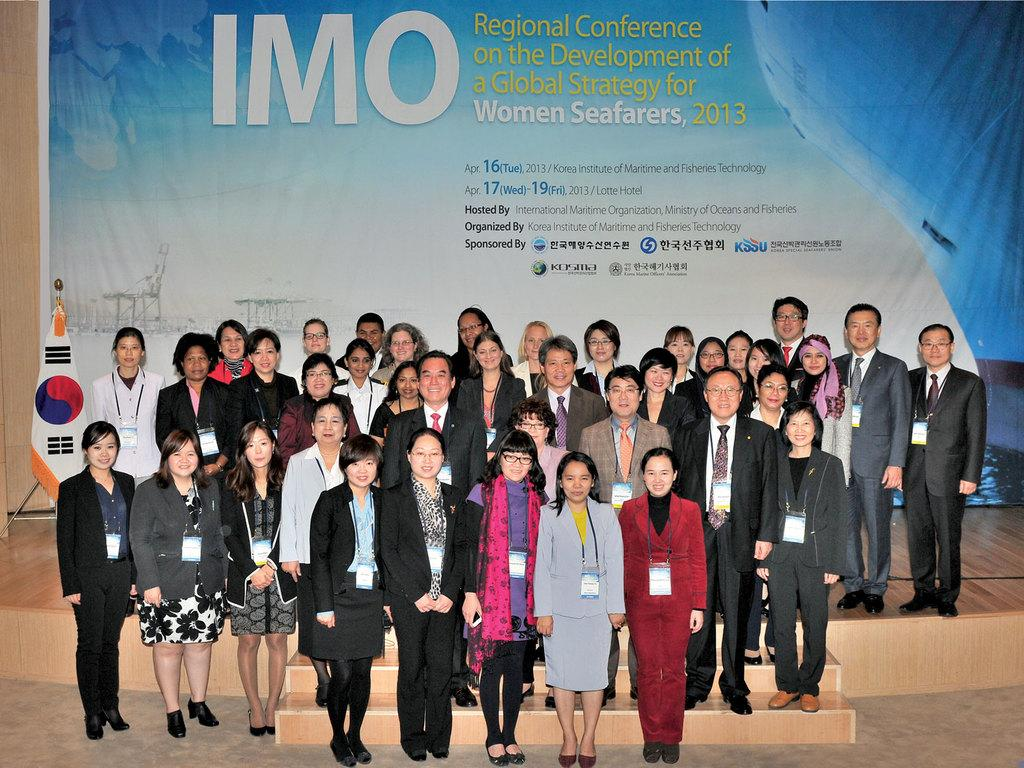How many people are in the image? There is a group of persons in the image, but the exact number is not specified. Where are the persons located in the image? The group of persons is standing at the bottom of the image. What can be seen in the background of the image? There is a poster wall in the background of the image. What type of record can be seen on the poster wall in the image? There is no record visible on the poster wall in the image. 